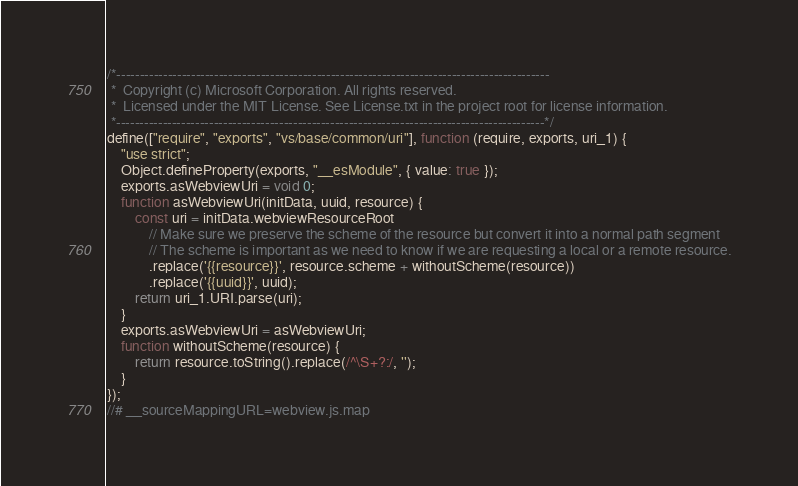<code> <loc_0><loc_0><loc_500><loc_500><_JavaScript_>/*---------------------------------------------------------------------------------------------
 *  Copyright (c) Microsoft Corporation. All rights reserved.
 *  Licensed under the MIT License. See License.txt in the project root for license information.
 *--------------------------------------------------------------------------------------------*/
define(["require", "exports", "vs/base/common/uri"], function (require, exports, uri_1) {
    "use strict";
    Object.defineProperty(exports, "__esModule", { value: true });
    exports.asWebviewUri = void 0;
    function asWebviewUri(initData, uuid, resource) {
        const uri = initData.webviewResourceRoot
            // Make sure we preserve the scheme of the resource but convert it into a normal path segment
            // The scheme is important as we need to know if we are requesting a local or a remote resource.
            .replace('{{resource}}', resource.scheme + withoutScheme(resource))
            .replace('{{uuid}}', uuid);
        return uri_1.URI.parse(uri);
    }
    exports.asWebviewUri = asWebviewUri;
    function withoutScheme(resource) {
        return resource.toString().replace(/^\S+?:/, '');
    }
});
//# __sourceMappingURL=webview.js.map</code> 